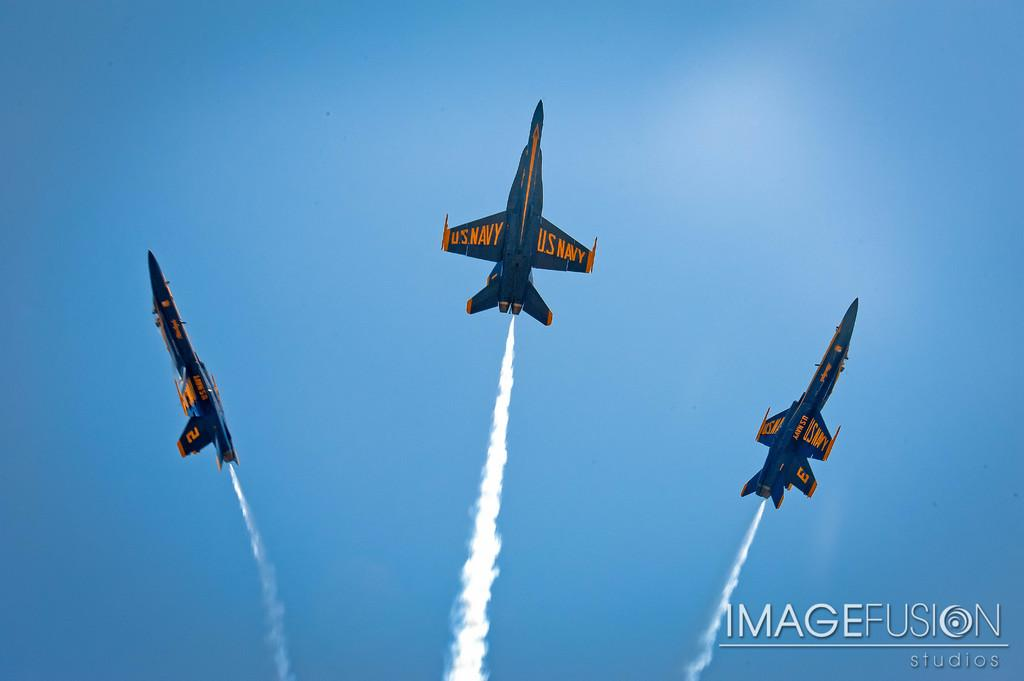What is the main subject of the image? The main subject of the image is three jets. What color is the background of the image? The background of the image is blue. Is there any additional information or branding present in the image? Yes, there is a watermark in the bottom right of the image. What type of expert can be seen playing with the jets in the image? There are no experts or any indication of play in the image; it simply features three jets with a blue background and a watermark. 